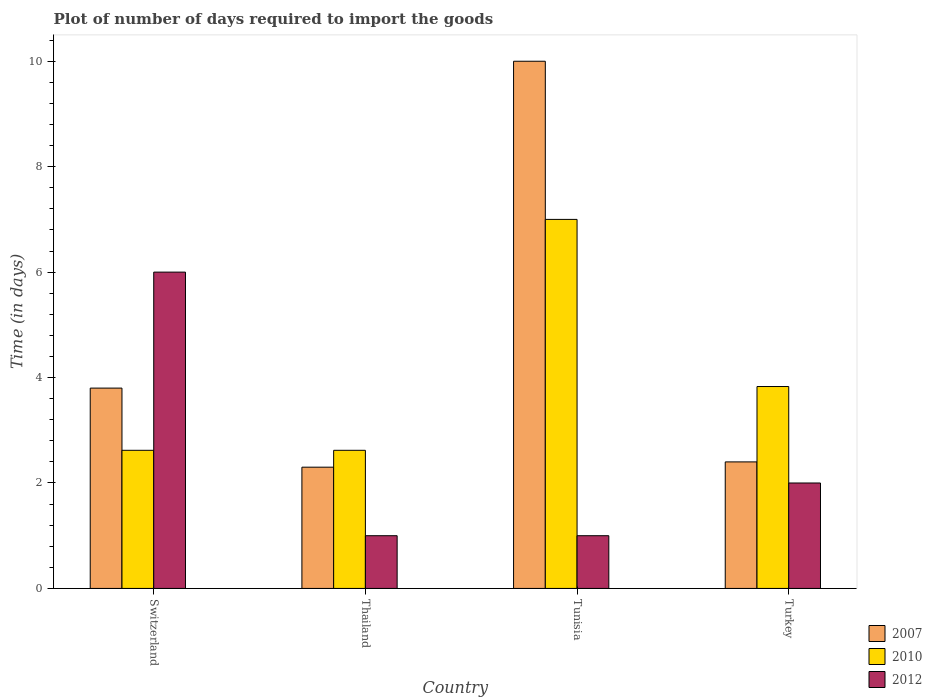How many different coloured bars are there?
Your response must be concise. 3. Are the number of bars on each tick of the X-axis equal?
Ensure brevity in your answer.  Yes. How many bars are there on the 4th tick from the right?
Offer a very short reply. 3. In how many cases, is the number of bars for a given country not equal to the number of legend labels?
Give a very brief answer. 0. Across all countries, what is the maximum time required to import goods in 2007?
Make the answer very short. 10. Across all countries, what is the minimum time required to import goods in 2010?
Provide a short and direct response. 2.62. In which country was the time required to import goods in 2012 maximum?
Your response must be concise. Switzerland. In which country was the time required to import goods in 2012 minimum?
Offer a terse response. Thailand. What is the total time required to import goods in 2010 in the graph?
Offer a terse response. 16.07. What is the difference between the time required to import goods in 2010 in Thailand and that in Tunisia?
Your answer should be compact. -4.38. What is the average time required to import goods in 2010 per country?
Offer a very short reply. 4.02. What is the difference between the time required to import goods of/in 2010 and time required to import goods of/in 2007 in Turkey?
Offer a terse response. 1.43. In how many countries, is the time required to import goods in 2012 greater than 7.6 days?
Ensure brevity in your answer.  0. What is the ratio of the time required to import goods in 2007 in Tunisia to that in Turkey?
Ensure brevity in your answer.  4.17. Is the time required to import goods in 2012 in Switzerland less than that in Turkey?
Ensure brevity in your answer.  No. What is the difference between the highest and the second highest time required to import goods in 2010?
Your answer should be compact. -1.21. In how many countries, is the time required to import goods in 2007 greater than the average time required to import goods in 2007 taken over all countries?
Offer a terse response. 1. Is the sum of the time required to import goods in 2012 in Switzerland and Thailand greater than the maximum time required to import goods in 2007 across all countries?
Keep it short and to the point. No. What does the 2nd bar from the left in Turkey represents?
Make the answer very short. 2010. How many countries are there in the graph?
Keep it short and to the point. 4. Where does the legend appear in the graph?
Your answer should be very brief. Bottom right. How are the legend labels stacked?
Your answer should be very brief. Vertical. What is the title of the graph?
Give a very brief answer. Plot of number of days required to import the goods. Does "1962" appear as one of the legend labels in the graph?
Keep it short and to the point. No. What is the label or title of the Y-axis?
Your response must be concise. Time (in days). What is the Time (in days) in 2010 in Switzerland?
Your response must be concise. 2.62. What is the Time (in days) of 2007 in Thailand?
Your answer should be compact. 2.3. What is the Time (in days) in 2010 in Thailand?
Provide a succinct answer. 2.62. What is the Time (in days) in 2010 in Tunisia?
Ensure brevity in your answer.  7. What is the Time (in days) in 2012 in Tunisia?
Your response must be concise. 1. What is the Time (in days) of 2007 in Turkey?
Provide a short and direct response. 2.4. What is the Time (in days) in 2010 in Turkey?
Offer a very short reply. 3.83. Across all countries, what is the minimum Time (in days) of 2010?
Ensure brevity in your answer.  2.62. What is the total Time (in days) in 2010 in the graph?
Provide a short and direct response. 16.07. What is the difference between the Time (in days) in 2007 in Switzerland and that in Thailand?
Offer a very short reply. 1.5. What is the difference between the Time (in days) in 2012 in Switzerland and that in Thailand?
Give a very brief answer. 5. What is the difference between the Time (in days) of 2007 in Switzerland and that in Tunisia?
Provide a succinct answer. -6.2. What is the difference between the Time (in days) of 2010 in Switzerland and that in Tunisia?
Provide a short and direct response. -4.38. What is the difference between the Time (in days) of 2012 in Switzerland and that in Tunisia?
Keep it short and to the point. 5. What is the difference between the Time (in days) of 2007 in Switzerland and that in Turkey?
Ensure brevity in your answer.  1.4. What is the difference between the Time (in days) in 2010 in Switzerland and that in Turkey?
Your answer should be very brief. -1.21. What is the difference between the Time (in days) in 2012 in Switzerland and that in Turkey?
Offer a terse response. 4. What is the difference between the Time (in days) of 2007 in Thailand and that in Tunisia?
Provide a succinct answer. -7.7. What is the difference between the Time (in days) of 2010 in Thailand and that in Tunisia?
Your response must be concise. -4.38. What is the difference between the Time (in days) of 2007 in Thailand and that in Turkey?
Make the answer very short. -0.1. What is the difference between the Time (in days) of 2010 in Thailand and that in Turkey?
Your response must be concise. -1.21. What is the difference between the Time (in days) of 2007 in Tunisia and that in Turkey?
Your answer should be very brief. 7.6. What is the difference between the Time (in days) in 2010 in Tunisia and that in Turkey?
Keep it short and to the point. 3.17. What is the difference between the Time (in days) in 2007 in Switzerland and the Time (in days) in 2010 in Thailand?
Offer a very short reply. 1.18. What is the difference between the Time (in days) of 2010 in Switzerland and the Time (in days) of 2012 in Thailand?
Provide a short and direct response. 1.62. What is the difference between the Time (in days) of 2007 in Switzerland and the Time (in days) of 2010 in Tunisia?
Provide a succinct answer. -3.2. What is the difference between the Time (in days) in 2007 in Switzerland and the Time (in days) in 2012 in Tunisia?
Your answer should be very brief. 2.8. What is the difference between the Time (in days) in 2010 in Switzerland and the Time (in days) in 2012 in Tunisia?
Keep it short and to the point. 1.62. What is the difference between the Time (in days) in 2007 in Switzerland and the Time (in days) in 2010 in Turkey?
Your response must be concise. -0.03. What is the difference between the Time (in days) of 2007 in Switzerland and the Time (in days) of 2012 in Turkey?
Keep it short and to the point. 1.8. What is the difference between the Time (in days) of 2010 in Switzerland and the Time (in days) of 2012 in Turkey?
Offer a very short reply. 0.62. What is the difference between the Time (in days) of 2007 in Thailand and the Time (in days) of 2012 in Tunisia?
Provide a short and direct response. 1.3. What is the difference between the Time (in days) in 2010 in Thailand and the Time (in days) in 2012 in Tunisia?
Offer a terse response. 1.62. What is the difference between the Time (in days) in 2007 in Thailand and the Time (in days) in 2010 in Turkey?
Provide a succinct answer. -1.53. What is the difference between the Time (in days) of 2007 in Thailand and the Time (in days) of 2012 in Turkey?
Give a very brief answer. 0.3. What is the difference between the Time (in days) in 2010 in Thailand and the Time (in days) in 2012 in Turkey?
Your response must be concise. 0.62. What is the difference between the Time (in days) of 2007 in Tunisia and the Time (in days) of 2010 in Turkey?
Offer a very short reply. 6.17. What is the difference between the Time (in days) in 2007 in Tunisia and the Time (in days) in 2012 in Turkey?
Provide a succinct answer. 8. What is the average Time (in days) of 2007 per country?
Give a very brief answer. 4.62. What is the average Time (in days) in 2010 per country?
Ensure brevity in your answer.  4.02. What is the difference between the Time (in days) in 2007 and Time (in days) in 2010 in Switzerland?
Your response must be concise. 1.18. What is the difference between the Time (in days) in 2010 and Time (in days) in 2012 in Switzerland?
Offer a very short reply. -3.38. What is the difference between the Time (in days) of 2007 and Time (in days) of 2010 in Thailand?
Provide a short and direct response. -0.32. What is the difference between the Time (in days) of 2007 and Time (in days) of 2012 in Thailand?
Offer a terse response. 1.3. What is the difference between the Time (in days) in 2010 and Time (in days) in 2012 in Thailand?
Ensure brevity in your answer.  1.62. What is the difference between the Time (in days) of 2007 and Time (in days) of 2012 in Tunisia?
Ensure brevity in your answer.  9. What is the difference between the Time (in days) of 2007 and Time (in days) of 2010 in Turkey?
Give a very brief answer. -1.43. What is the difference between the Time (in days) in 2007 and Time (in days) in 2012 in Turkey?
Keep it short and to the point. 0.4. What is the difference between the Time (in days) of 2010 and Time (in days) of 2012 in Turkey?
Your response must be concise. 1.83. What is the ratio of the Time (in days) of 2007 in Switzerland to that in Thailand?
Ensure brevity in your answer.  1.65. What is the ratio of the Time (in days) in 2010 in Switzerland to that in Thailand?
Your response must be concise. 1. What is the ratio of the Time (in days) in 2012 in Switzerland to that in Thailand?
Your answer should be very brief. 6. What is the ratio of the Time (in days) in 2007 in Switzerland to that in Tunisia?
Give a very brief answer. 0.38. What is the ratio of the Time (in days) in 2010 in Switzerland to that in Tunisia?
Your answer should be compact. 0.37. What is the ratio of the Time (in days) of 2012 in Switzerland to that in Tunisia?
Offer a terse response. 6. What is the ratio of the Time (in days) of 2007 in Switzerland to that in Turkey?
Offer a terse response. 1.58. What is the ratio of the Time (in days) of 2010 in Switzerland to that in Turkey?
Your response must be concise. 0.68. What is the ratio of the Time (in days) of 2012 in Switzerland to that in Turkey?
Your response must be concise. 3. What is the ratio of the Time (in days) in 2007 in Thailand to that in Tunisia?
Offer a very short reply. 0.23. What is the ratio of the Time (in days) in 2010 in Thailand to that in Tunisia?
Offer a very short reply. 0.37. What is the ratio of the Time (in days) of 2012 in Thailand to that in Tunisia?
Keep it short and to the point. 1. What is the ratio of the Time (in days) of 2010 in Thailand to that in Turkey?
Keep it short and to the point. 0.68. What is the ratio of the Time (in days) in 2012 in Thailand to that in Turkey?
Offer a terse response. 0.5. What is the ratio of the Time (in days) of 2007 in Tunisia to that in Turkey?
Give a very brief answer. 4.17. What is the ratio of the Time (in days) in 2010 in Tunisia to that in Turkey?
Offer a very short reply. 1.83. What is the difference between the highest and the second highest Time (in days) in 2010?
Provide a succinct answer. 3.17. What is the difference between the highest and the lowest Time (in days) in 2010?
Offer a very short reply. 4.38. 